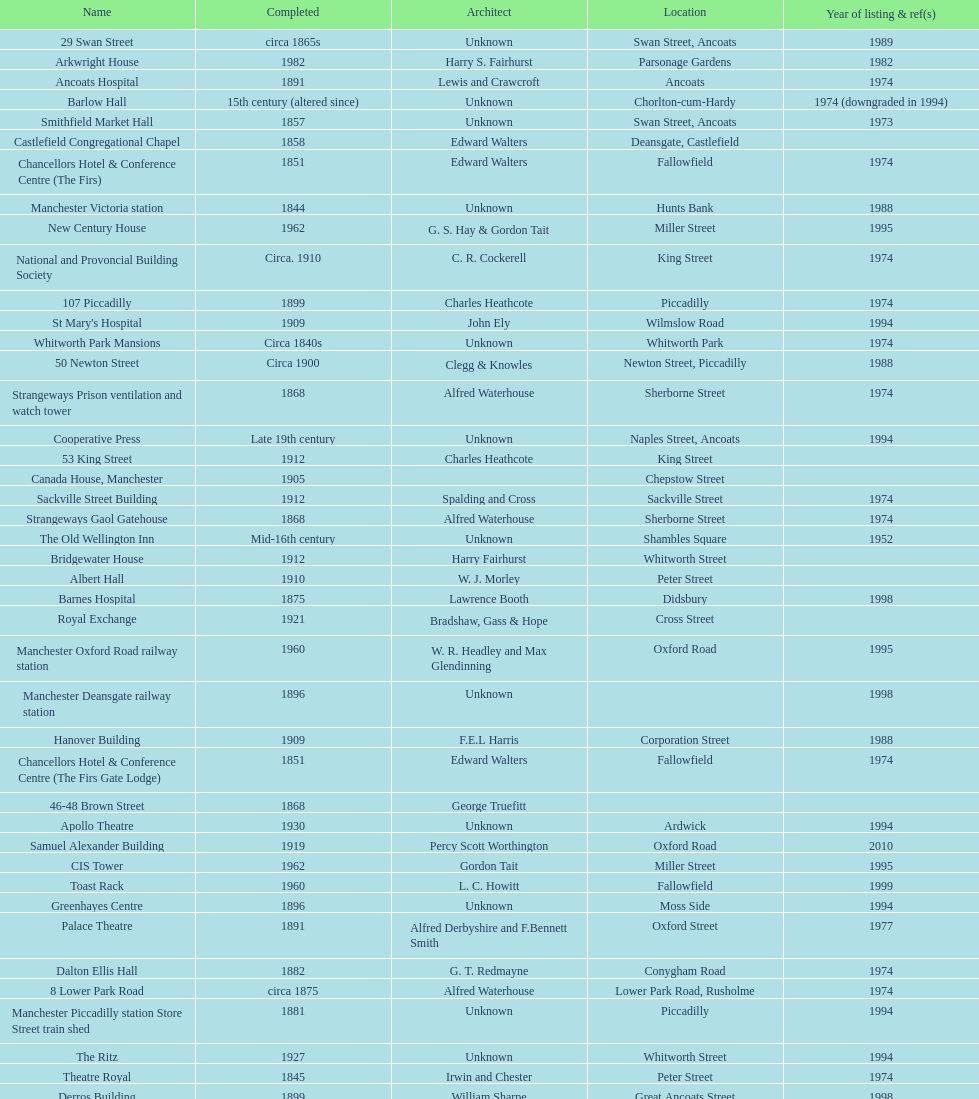What is the number of buildings listed in the year 1974? 15. 